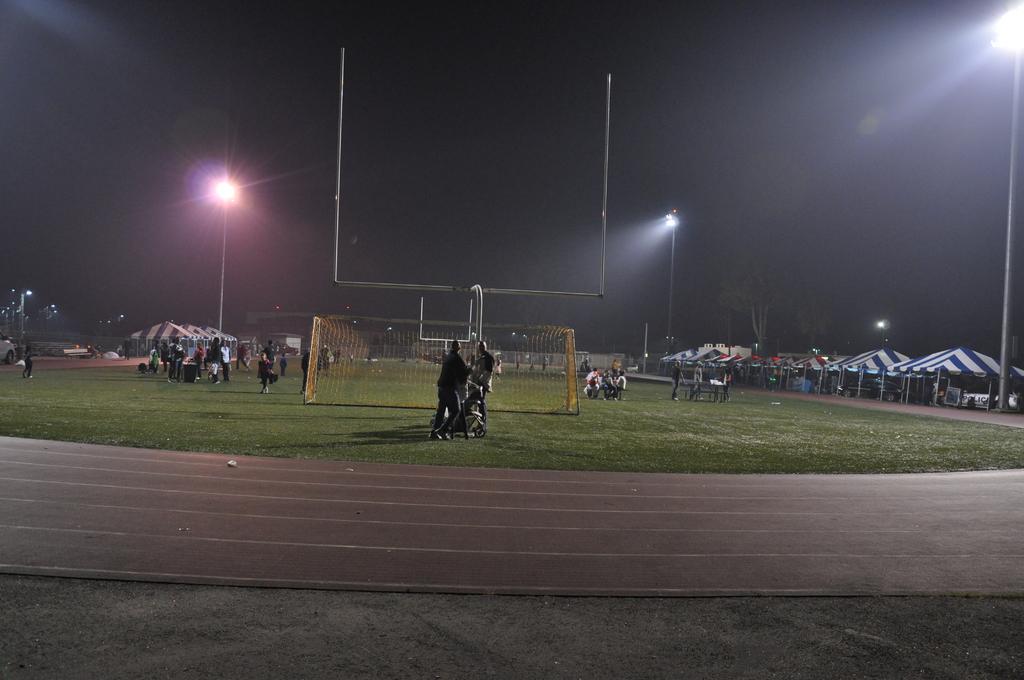How would you summarize this image in a sentence or two? This image is clicked in a ground. There are so many people in the middle. There are tents on the left side and right side. There are lights in the middle and top. There is sky at the top. There is net in the middle. 